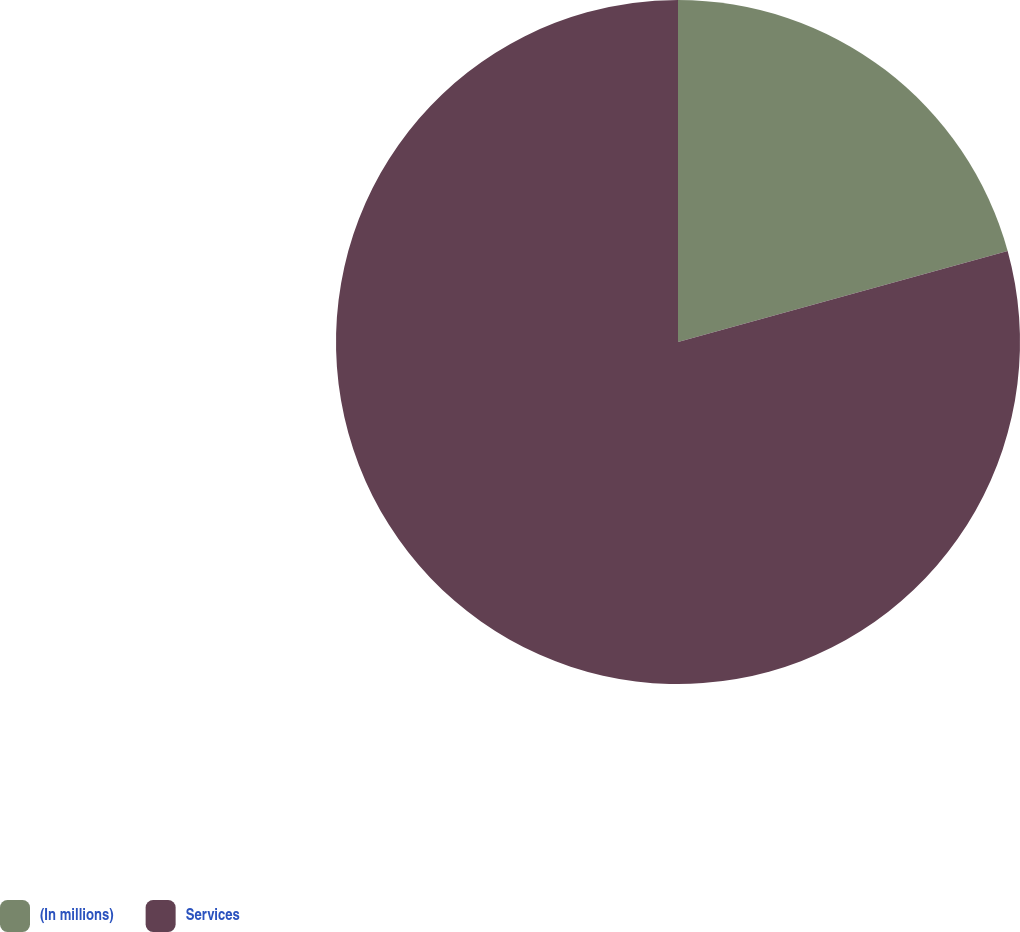Convert chart to OTSL. <chart><loc_0><loc_0><loc_500><loc_500><pie_chart><fcel>(In millions)<fcel>Services<nl><fcel>20.71%<fcel>79.29%<nl></chart> 